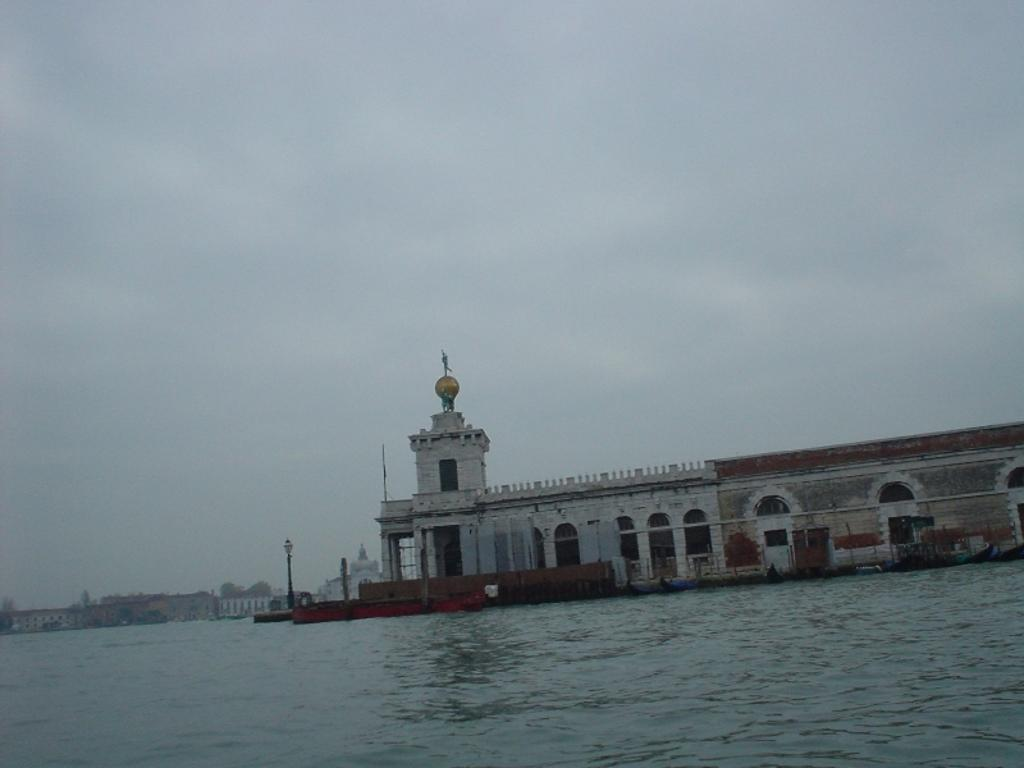What type of structures can be seen in the image? There are buildings in the image. What feature is visible on the buildings? There are windows visible in the image. What type of street furniture can be seen in the image? There are light poles in the image. What type of vegetation is present in the image? There are trees in the image. What natural feature can be seen in the image? There is a river in the image. What is visible above the buildings and trees in the image? The sky is visible in the image. Can you see a drum being played by a person in the image? There is no drum or person playing a drum present in the image. How many fingers are visible on the trees in the image? Trees do not have fingers, so this question cannot be answered. 